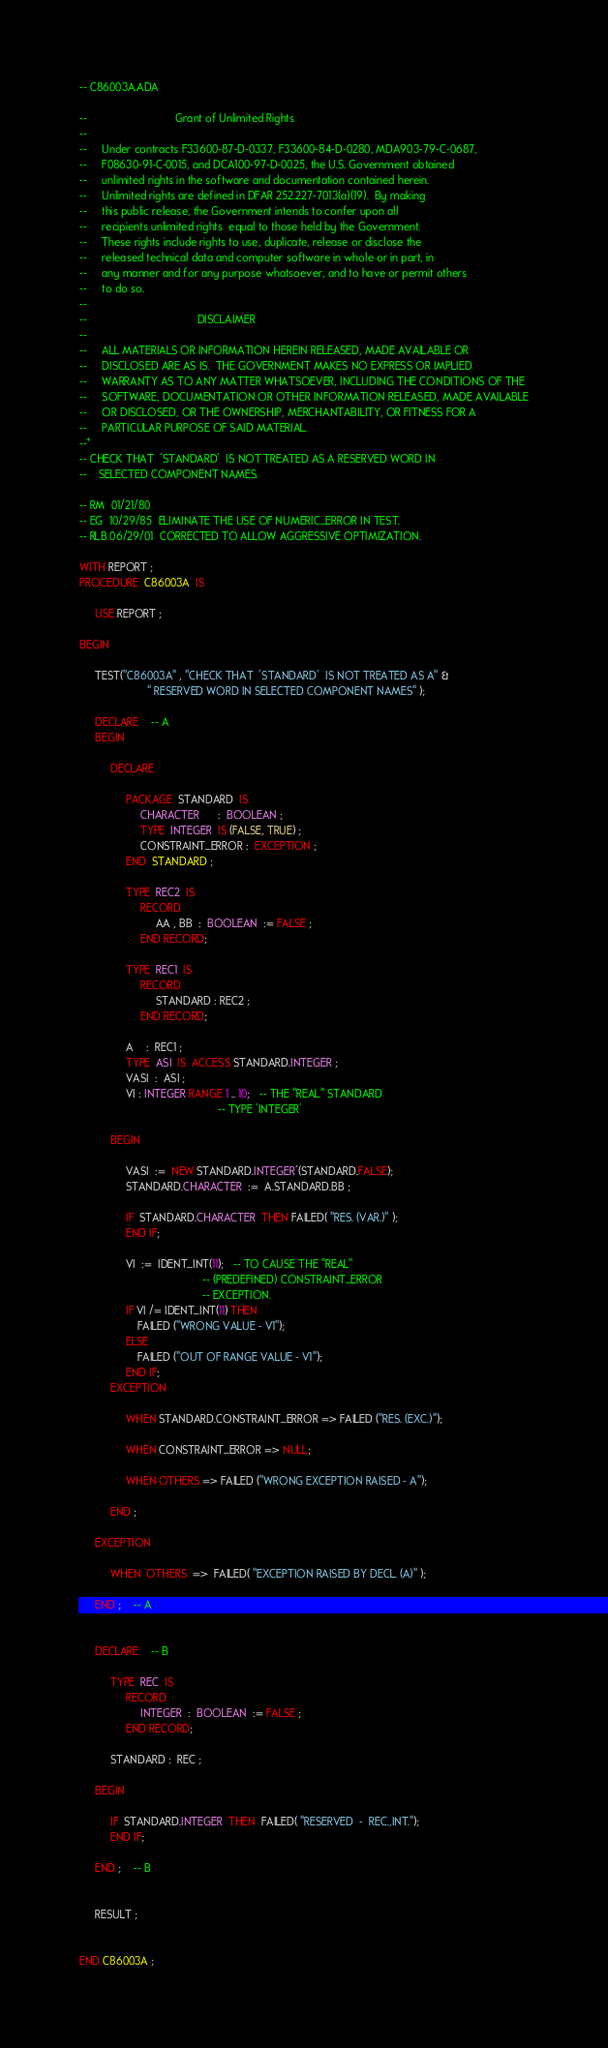<code> <loc_0><loc_0><loc_500><loc_500><_Ada_>-- C86003A.ADA

--                             Grant of Unlimited Rights
--
--     Under contracts F33600-87-D-0337, F33600-84-D-0280, MDA903-79-C-0687,
--     F08630-91-C-0015, and DCA100-97-D-0025, the U.S. Government obtained
--     unlimited rights in the software and documentation contained herein.
--     Unlimited rights are defined in DFAR 252.227-7013(a)(19).  By making
--     this public release, the Government intends to confer upon all
--     recipients unlimited rights  equal to those held by the Government.
--     These rights include rights to use, duplicate, release or disclose the
--     released technical data and computer software in whole or in part, in
--     any manner and for any purpose whatsoever, and to have or permit others
--     to do so.
--
--                                    DISCLAIMER
--
--     ALL MATERIALS OR INFORMATION HEREIN RELEASED, MADE AVAILABLE OR
--     DISCLOSED ARE AS IS.  THE GOVERNMENT MAKES NO EXPRESS OR IMPLIED
--     WARRANTY AS TO ANY MATTER WHATSOEVER, INCLUDING THE CONDITIONS OF THE
--     SOFTWARE, DOCUMENTATION OR OTHER INFORMATION RELEASED, MADE AVAILABLE
--     OR DISCLOSED, OR THE OWNERSHIP, MERCHANTABILITY, OR FITNESS FOR A
--     PARTICULAR PURPOSE OF SAID MATERIAL.
--*
-- CHECK THAT  'STANDARD'  IS NOT TREATED AS A RESERVED WORD IN
--    SELECTED COMPONENT NAMES.

-- RM  01/21/80
-- EG  10/29/85  ELIMINATE THE USE OF NUMERIC_ERROR IN TEST.
-- RLB 06/29/01  CORRECTED TO ALLOW AGGRESSIVE OPTIMIZATION.

WITH REPORT ;
PROCEDURE  C86003A  IS

     USE REPORT ;

BEGIN

     TEST("C86003A" , "CHECK THAT  'STANDARD'  IS NOT TREATED AS A" &
                      " RESERVED WORD IN SELECTED COMPONENT NAMES" );

     DECLARE    -- A
     BEGIN

          DECLARE

               PACKAGE  STANDARD  IS
                    CHARACTER      :  BOOLEAN ;
                    TYPE  INTEGER  IS (FALSE, TRUE) ;
                    CONSTRAINT_ERROR :  EXCEPTION ;
               END  STANDARD ;

               TYPE  REC2  IS
                    RECORD
                         AA , BB  :  BOOLEAN  := FALSE ;
                    END RECORD;

               TYPE  REC1  IS
                    RECORD
                         STANDARD : REC2 ;
                    END RECORD;

               A    :  REC1 ;
               TYPE  ASI  IS  ACCESS STANDARD.INTEGER ;
               VASI  :  ASI ;
               VI : INTEGER RANGE 1 .. 10;   -- THE "REAL" STANDARD
                                             -- TYPE 'INTEGER'

          BEGIN

               VASI  :=  NEW STANDARD.INTEGER'(STANDARD.FALSE);
               STANDARD.CHARACTER  :=  A.STANDARD.BB ;

               IF  STANDARD.CHARACTER  THEN FAILED( "RES. (VAR.)" );
               END IF;

               VI  :=  IDENT_INT(11);   -- TO CAUSE THE "REAL"
                                        -- (PREDEFINED) CONSTRAINT_ERROR
                                        -- EXCEPTION.
               IF VI /= IDENT_INT(11) THEN
                   FAILED ("WRONG VALUE - V1");
               ELSE
                   FAILED ("OUT OF RANGE VALUE - V1");
               END IF;
          EXCEPTION

               WHEN STANDARD.CONSTRAINT_ERROR => FAILED ("RES. (EXC.)");

               WHEN CONSTRAINT_ERROR => NULL;

               WHEN OTHERS => FAILED ("WRONG EXCEPTION RAISED - A");

          END ;

     EXCEPTION

          WHEN  OTHERS  =>  FAILED( "EXCEPTION RAISED BY DECL. (A)" );

     END ;    -- A


     DECLARE    -- B

          TYPE  REC  IS
               RECORD
                    INTEGER  :  BOOLEAN  := FALSE ;
               END RECORD;

          STANDARD :  REC ;

     BEGIN

          IF  STANDARD.INTEGER  THEN  FAILED( "RESERVED  -  REC.,INT.");
          END IF;

     END ;    -- B


     RESULT ;


END C86003A ;
</code> 